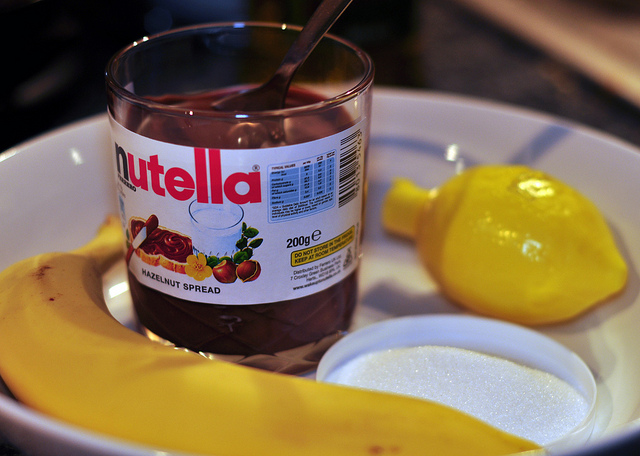<image>What fruit is pictured next to the bottle? I am not sure what fruit is pictured next to the bottle. It can be a banana or a lemon. What fruit is pictured next to the bottle? I don't know what fruit is pictured next to the bottle. It could be a banana or a lemon. 